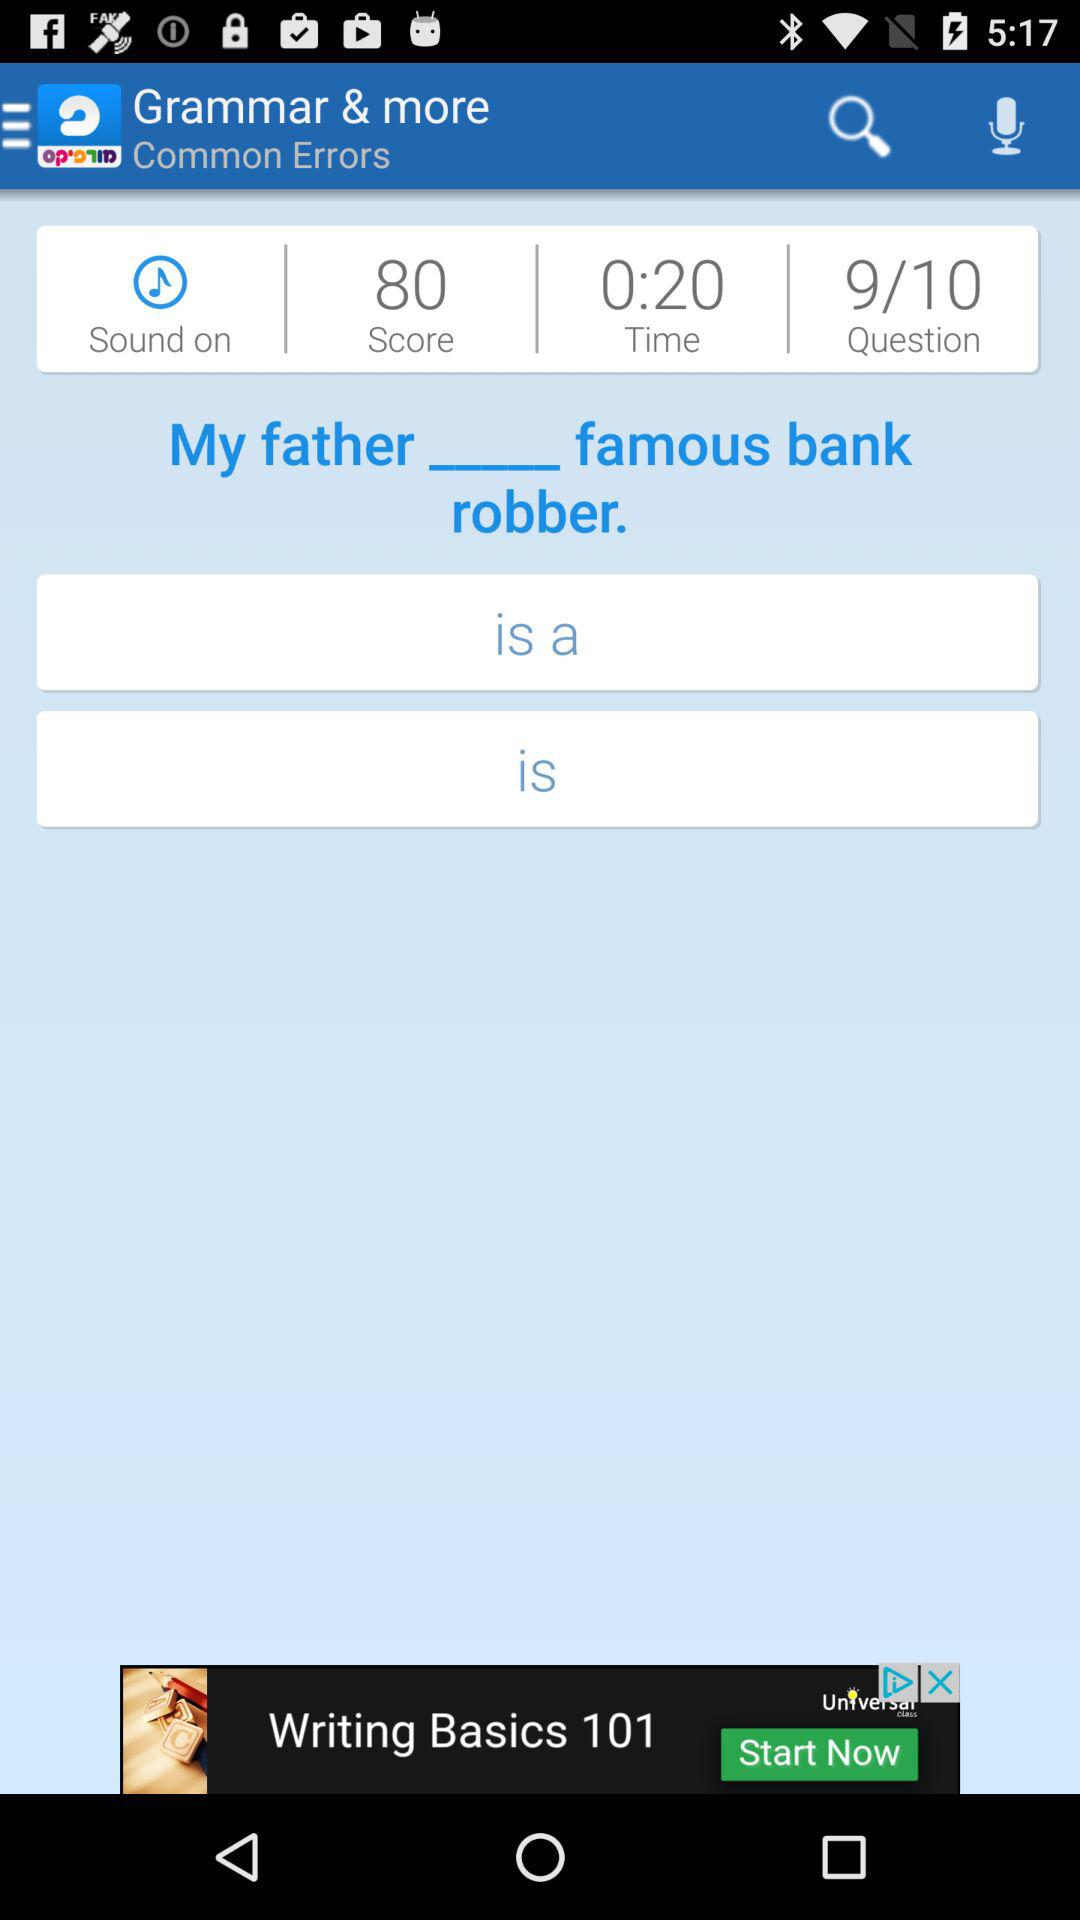What is the application name? The application name is "Morfix". 